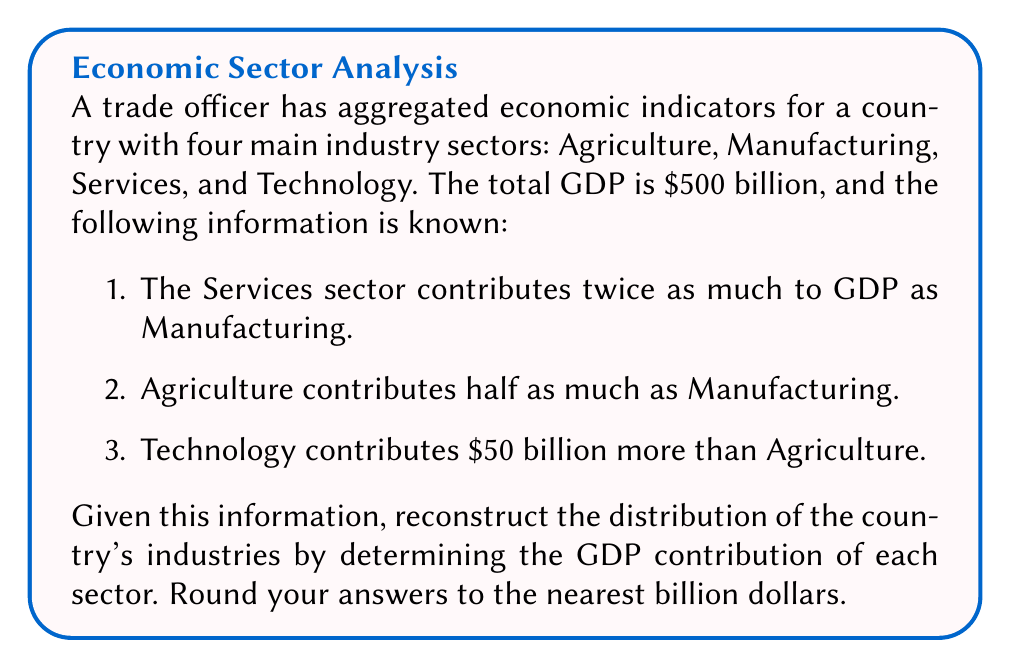Solve this math problem. Let's approach this step-by-step:

1) Let's define variables for each sector:
   A = Agriculture
   M = Manufacturing
   S = Services
   T = Technology

2) We can write equations based on the given information:
   S = 2M (Services is twice Manufacturing)
   A = 0.5M (Agriculture is half of Manufacturing)
   T = A + 50 (Technology is $50 billion more than Agriculture)

3) We know the total GDP is $500 billion, so:
   A + M + S + T = 500

4) Substituting the relationships we know:
   0.5M + M + 2M + (0.5M + 50) = 500

5) Simplify:
   4M + 50 = 500

6) Solve for M:
   4M = 450
   M = 112.5

7) Now we can calculate the other sectors:
   A = 0.5M = 0.5 * 112.5 = 56.25
   S = 2M = 2 * 112.5 = 225
   T = A + 50 = 56.25 + 50 = 106.25

8) Rounding to the nearest billion:
   Agriculture: $56 billion
   Manufacturing: $113 billion
   Services: $225 billion
   Technology: $106 billion

9) Verify: 56 + 113 + 225 + 106 = 500 billion (total GDP)
Answer: Agriculture: $56 billion, Manufacturing: $113 billion, Services: $225 billion, Technology: $106 billion 